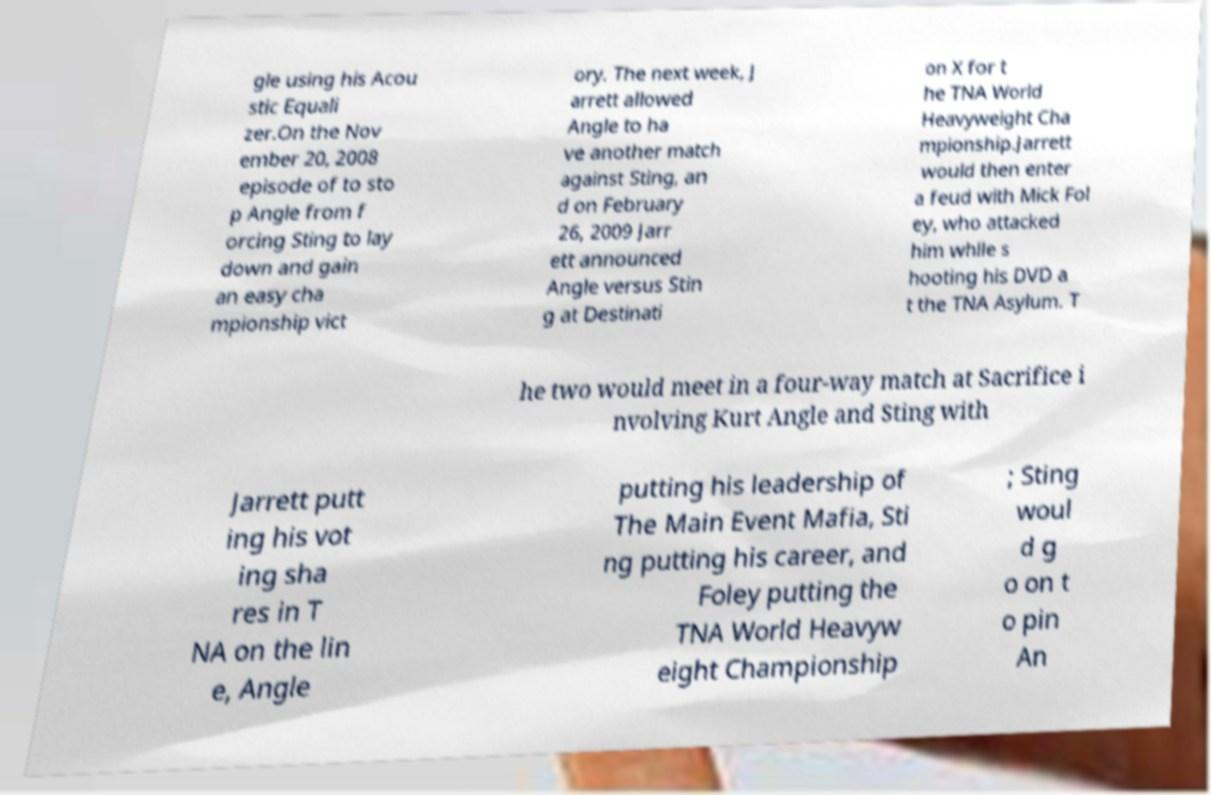Please identify and transcribe the text found in this image. gle using his Acou stic Equali zer.On the Nov ember 20, 2008 episode of to sto p Angle from f orcing Sting to lay down and gain an easy cha mpionship vict ory. The next week, J arrett allowed Angle to ha ve another match against Sting, an d on February 26, 2009 Jarr ett announced Angle versus Stin g at Destinati on X for t he TNA World Heavyweight Cha mpionship.Jarrett would then enter a feud with Mick Fol ey, who attacked him while s hooting his DVD a t the TNA Asylum. T he two would meet in a four-way match at Sacrifice i nvolving Kurt Angle and Sting with Jarrett putt ing his vot ing sha res in T NA on the lin e, Angle putting his leadership of The Main Event Mafia, Sti ng putting his career, and Foley putting the TNA World Heavyw eight Championship ; Sting woul d g o on t o pin An 